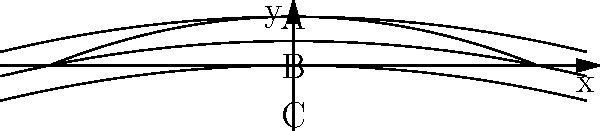In the context of international diplomacy and aeronautical engineering cooperation, consider the airfoil shape and flow patterns shown in the diagram. Which point (A, B, or C) is likely to experience the highest velocity, and how might this knowledge influence diplomatic negotiations for technology sharing in the aerospace industry? To answer this question, we need to consider the principles of fluid dynamics and their application to airfoil design:

1. Bernoulli's principle: As fluid velocity increases, pressure decreases, and vice versa.

2. Airfoil shape: The airfoil in the diagram has a curved upper surface and a relatively flat lower surface.

3. Flow patterns: The streamlines are closer together above the airfoil (near point A) compared to below it (near point C).

4. Continuity equation: For incompressible flow, the product of velocity and area remains constant. As the area between streamlines decreases, velocity must increase.

5. Analysis of points:
   - Point A: Streamlines are closest together, indicating the smallest area and thus the highest velocity.
   - Point B: On the surface of the airfoil, velocity is theoretically zero (no-slip condition).
   - Point C: Streamlines are further apart than at point A, indicating lower velocity.

6. Diplomatic implications:
   - Knowledge of advanced airfoil designs can be a valuable asset in international negotiations.
   - Countries with expertise in high-efficiency airfoils may have leverage in aerospace technology sharing agreements.
   - Understanding the physics behind airfoil performance can inform discussions on aircraft performance, fuel efficiency, and environmental impact.

Therefore, point A is likely to experience the highest velocity. This knowledge could be used as a bargaining chip in diplomatic negotiations, potentially influencing technology transfer agreements, joint research initiatives, or trade deals in the aerospace sector.
Answer: Point A; highest velocity knowledge can leverage aerospace technology sharing negotiations. 